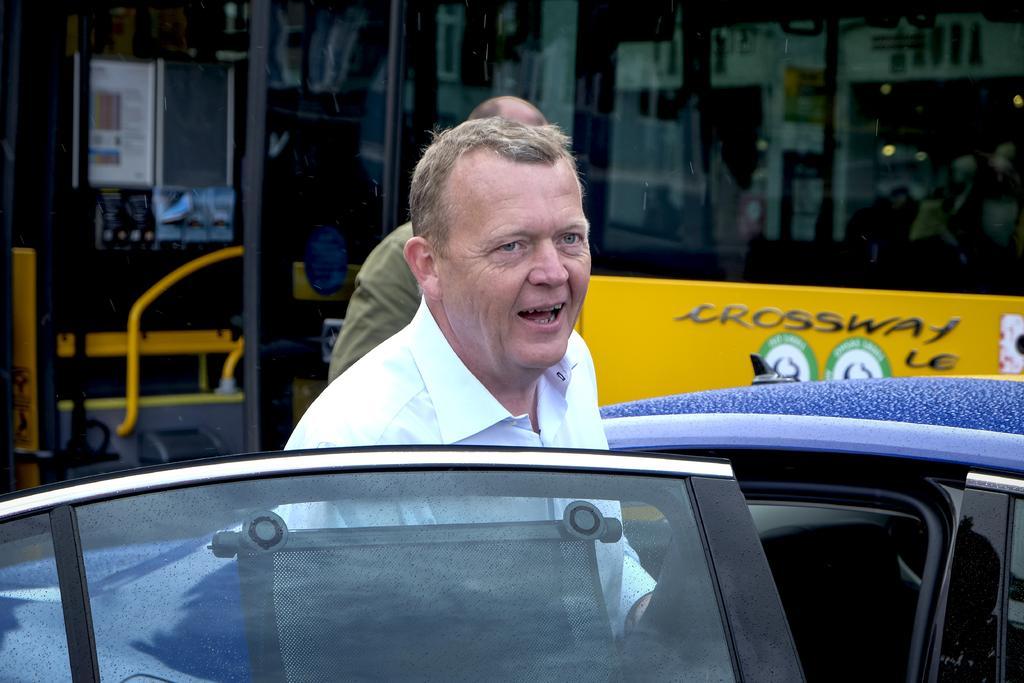How would you summarize this image in a sentence or two? In this image there is a person standing behind the car door. Behind him there is another person. In the background of the image there is a bus. 